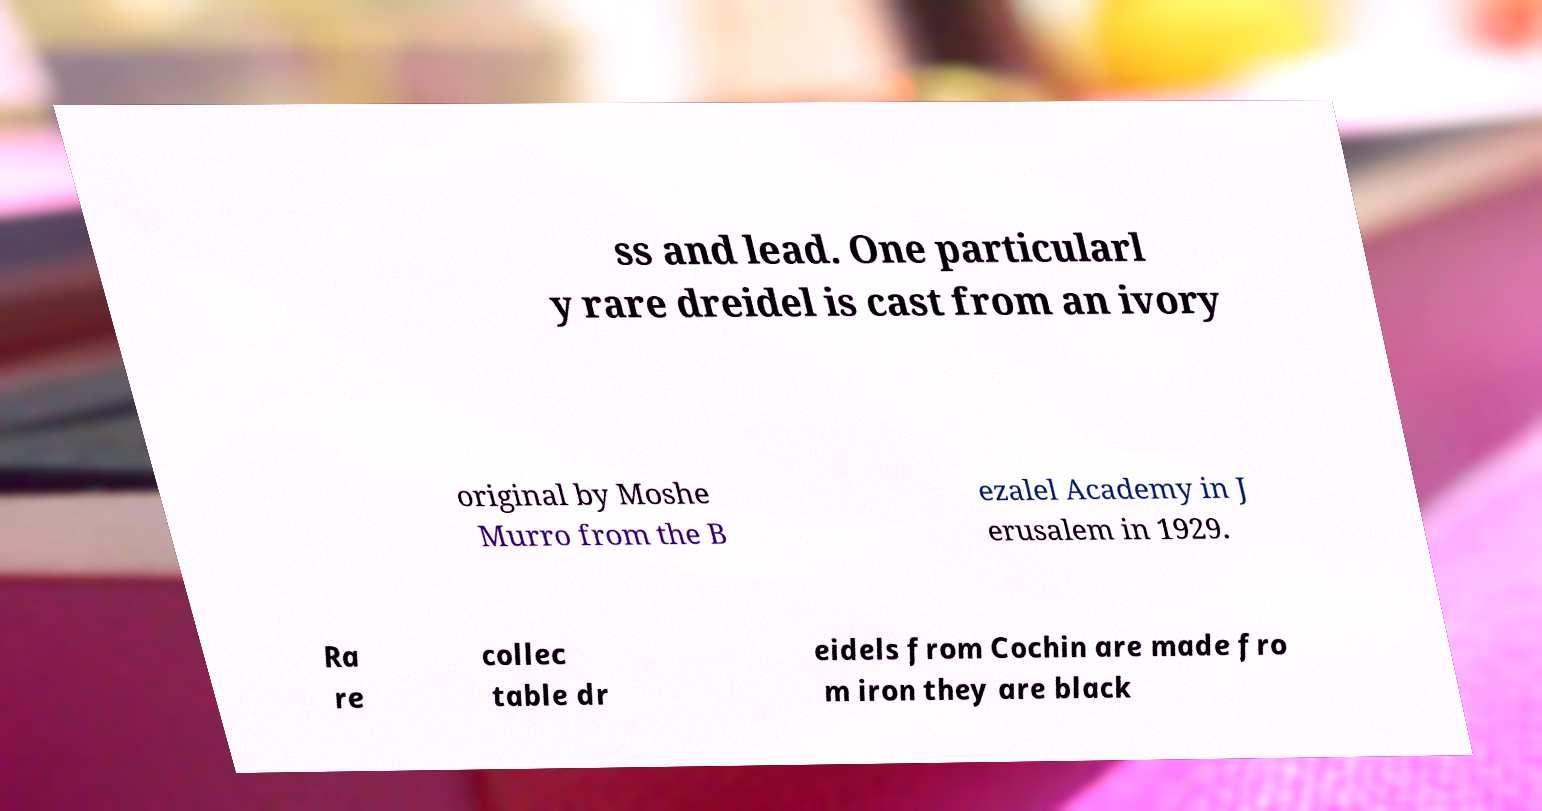Can you read and provide the text displayed in the image?This photo seems to have some interesting text. Can you extract and type it out for me? ss and lead. One particularl y rare dreidel is cast from an ivory original by Moshe Murro from the B ezalel Academy in J erusalem in 1929. Ra re collec table dr eidels from Cochin are made fro m iron they are black 